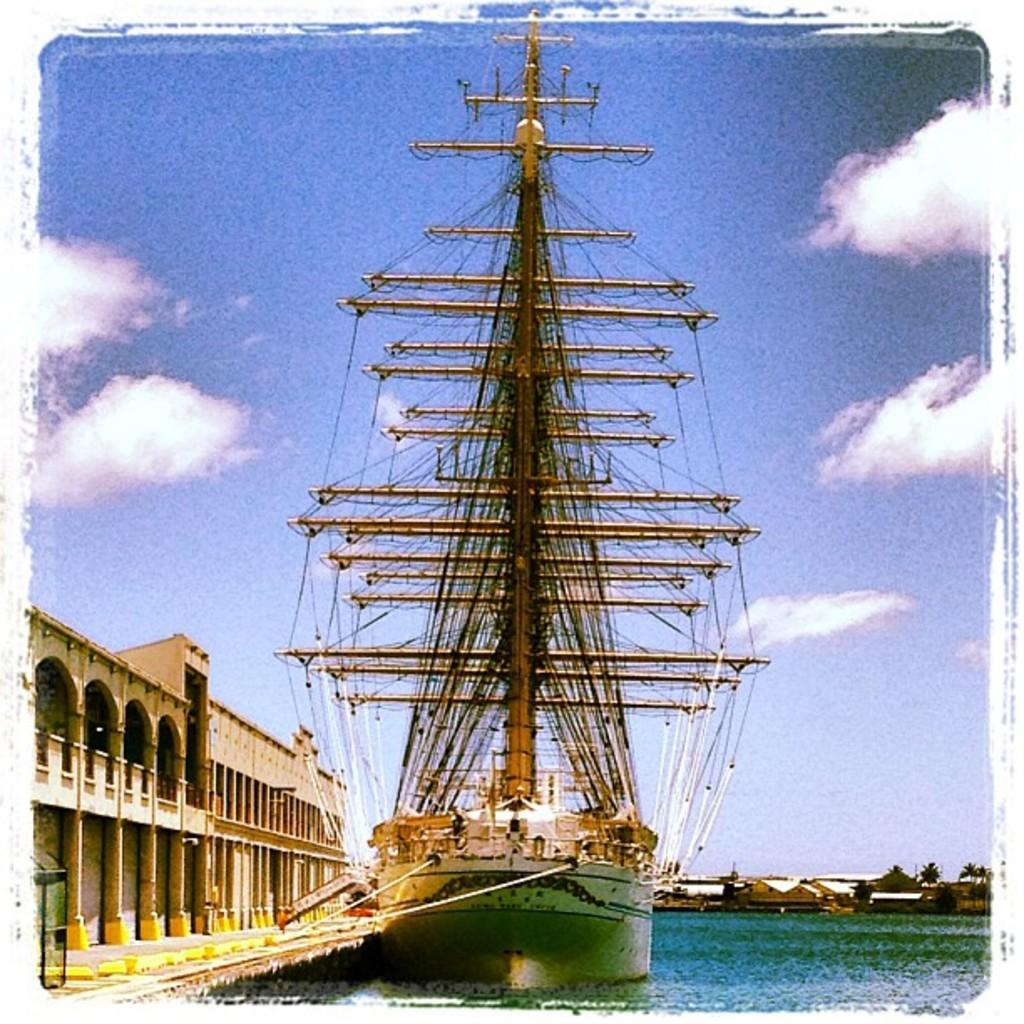What is the main subject of the image? There is a ship in the image. Where is the ship located? The ship is on the water. What can be seen beside the ship? There is a building beside the ship. What is visible in the background of the image? There are buildings, trees, and the sky in the background of the image. What is the condition of the sky in the image? Clouds are present in the sky. What type of hammer is being used to prepare the feast on the ship? There is no hammer or feast present in the image; it features a ship on the water with a building beside it and a background of buildings, trees, and clouds in the sky. 